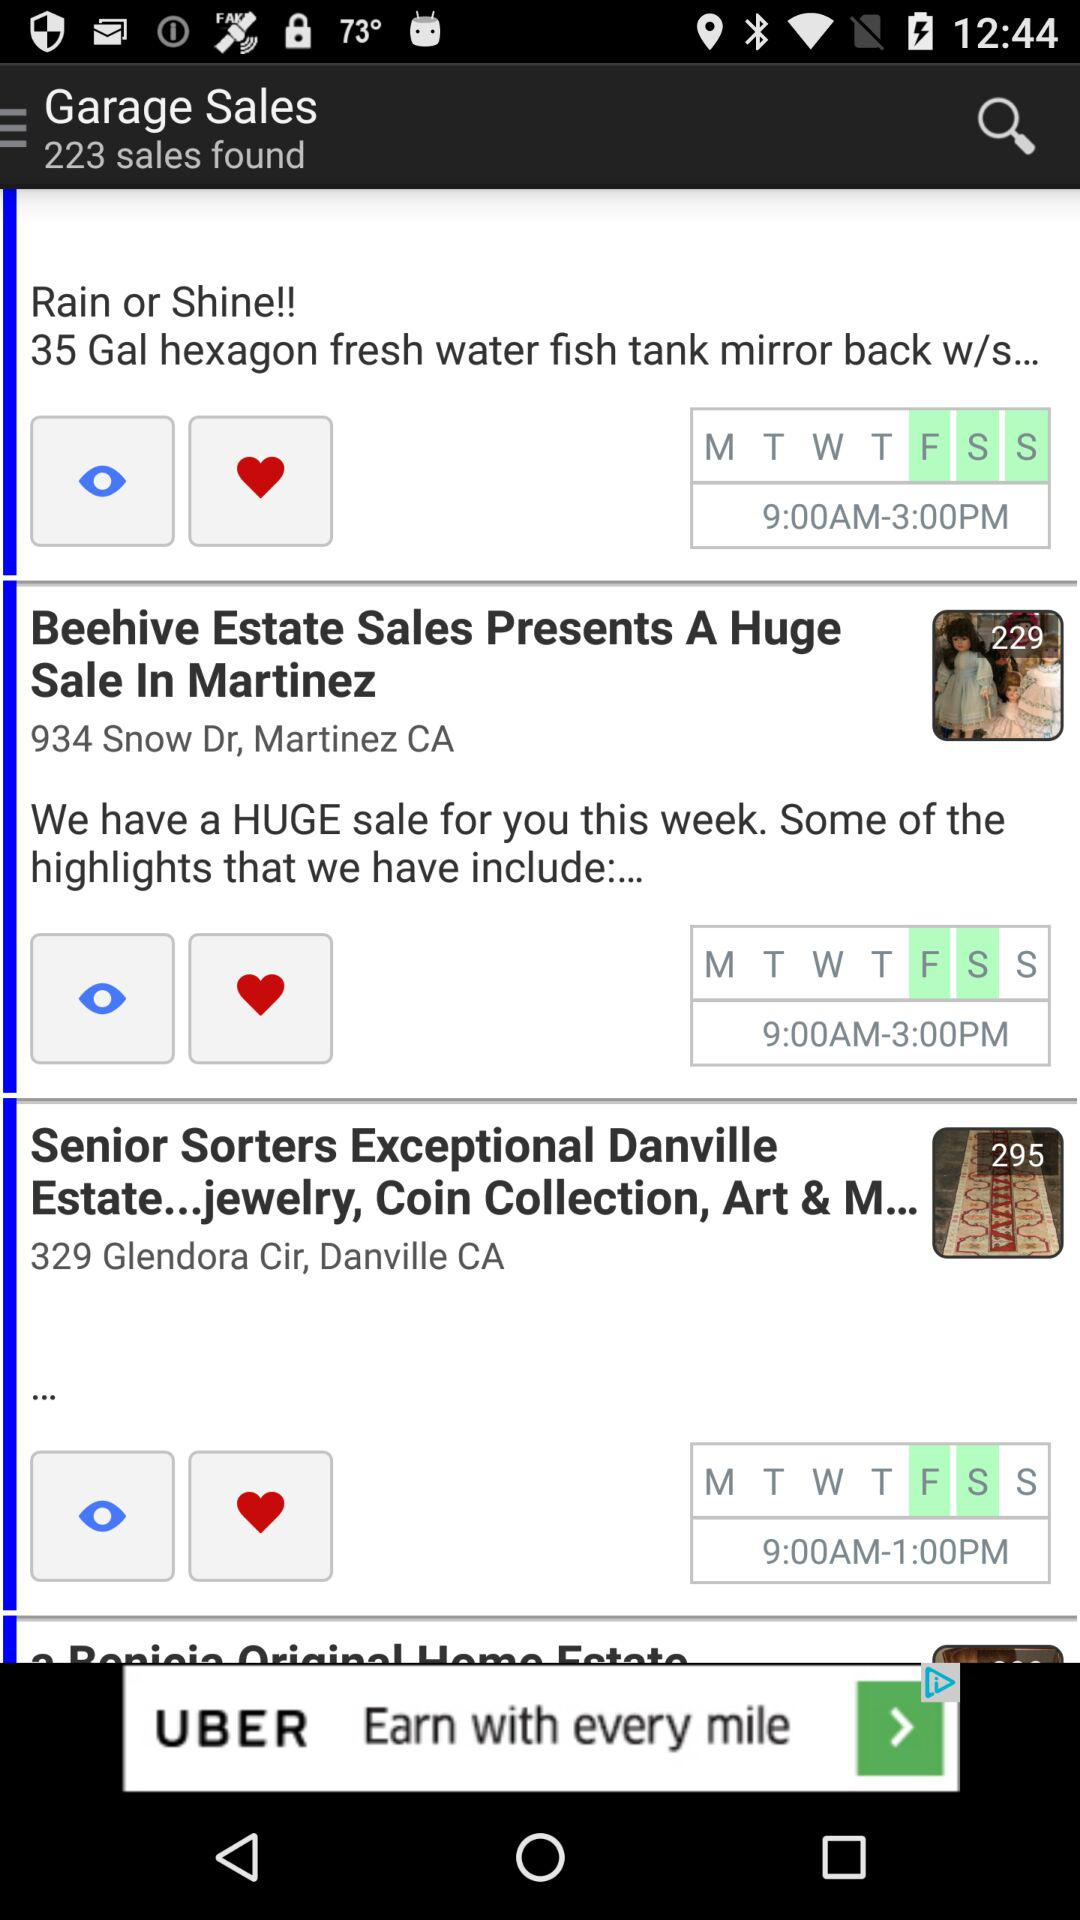What is the schedule day for "Beehive Estate Sales"? The scheduled days for "Beehive Estate Sales" are Friday and Saturday. 